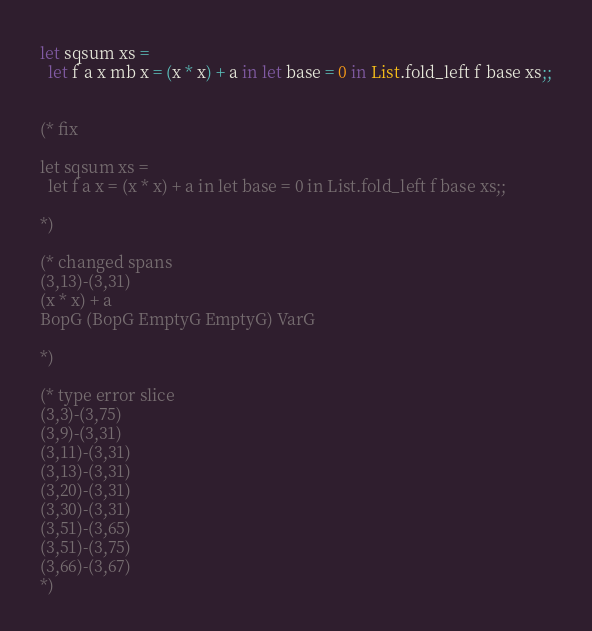<code> <loc_0><loc_0><loc_500><loc_500><_OCaml_>
let sqsum xs =
  let f a x mb x = (x * x) + a in let base = 0 in List.fold_left f base xs;;


(* fix

let sqsum xs =
  let f a x = (x * x) + a in let base = 0 in List.fold_left f base xs;;

*)

(* changed spans
(3,13)-(3,31)
(x * x) + a
BopG (BopG EmptyG EmptyG) VarG

*)

(* type error slice
(3,3)-(3,75)
(3,9)-(3,31)
(3,11)-(3,31)
(3,13)-(3,31)
(3,20)-(3,31)
(3,30)-(3,31)
(3,51)-(3,65)
(3,51)-(3,75)
(3,66)-(3,67)
*)
</code> 